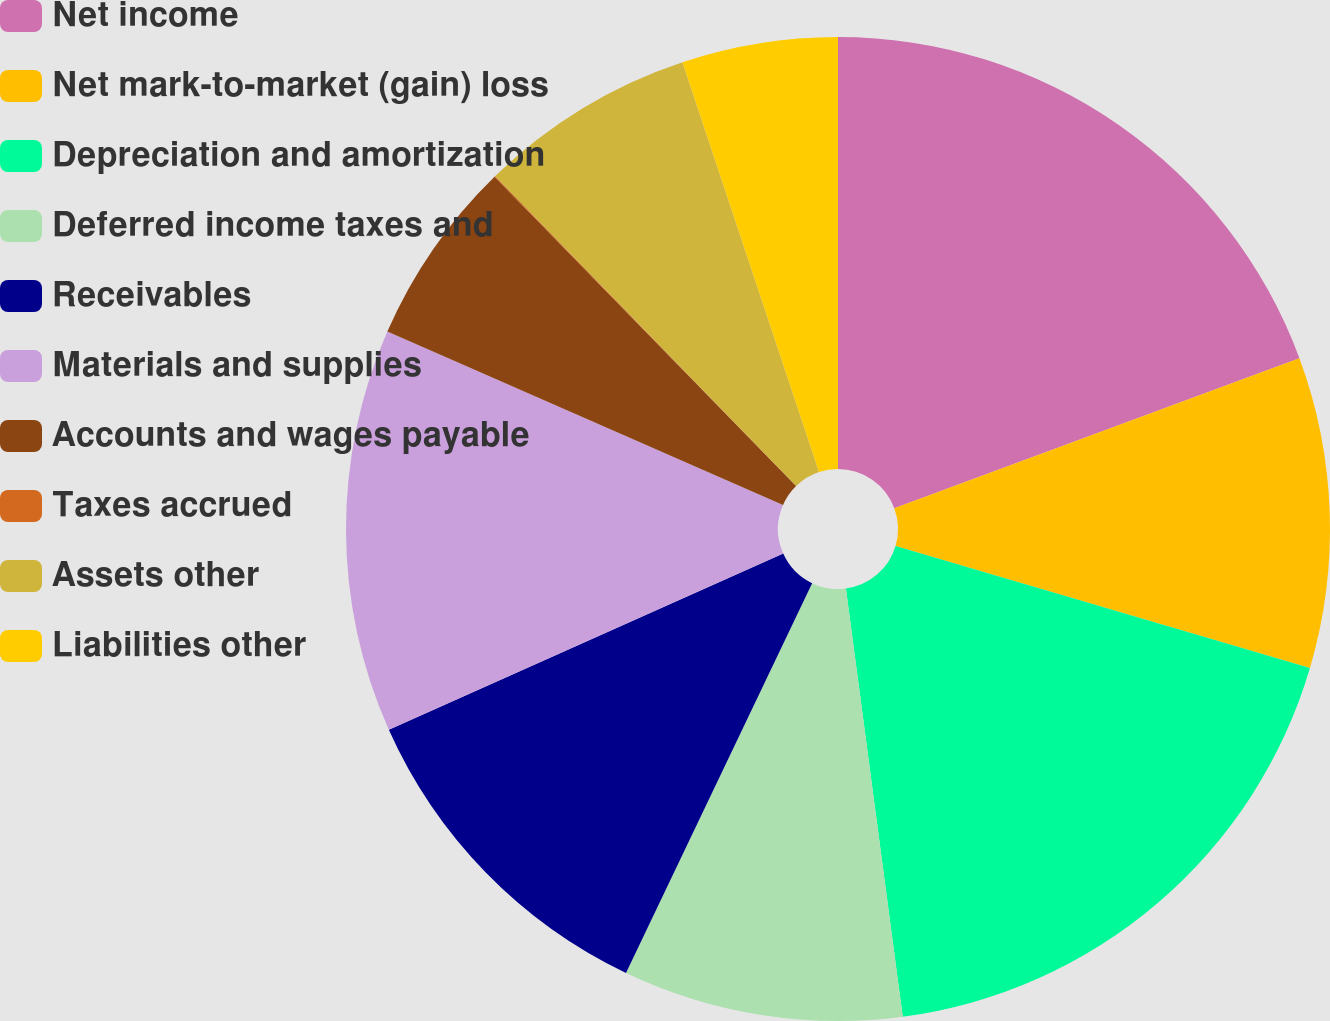<chart> <loc_0><loc_0><loc_500><loc_500><pie_chart><fcel>Net income<fcel>Net mark-to-market (gain) loss<fcel>Depreciation and amortization<fcel>Deferred income taxes and<fcel>Receivables<fcel>Materials and supplies<fcel>Accounts and wages payable<fcel>Taxes accrued<fcel>Assets other<fcel>Liabilities other<nl><fcel>19.36%<fcel>10.2%<fcel>18.34%<fcel>9.19%<fcel>11.22%<fcel>13.26%<fcel>6.13%<fcel>0.03%<fcel>7.15%<fcel>5.12%<nl></chart> 